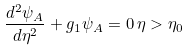<formula> <loc_0><loc_0><loc_500><loc_500>\frac { d ^ { 2 } \psi _ { A } } { d \eta ^ { 2 } } + g _ { 1 } \psi _ { A } = 0 \, \eta > \eta _ { 0 }</formula> 